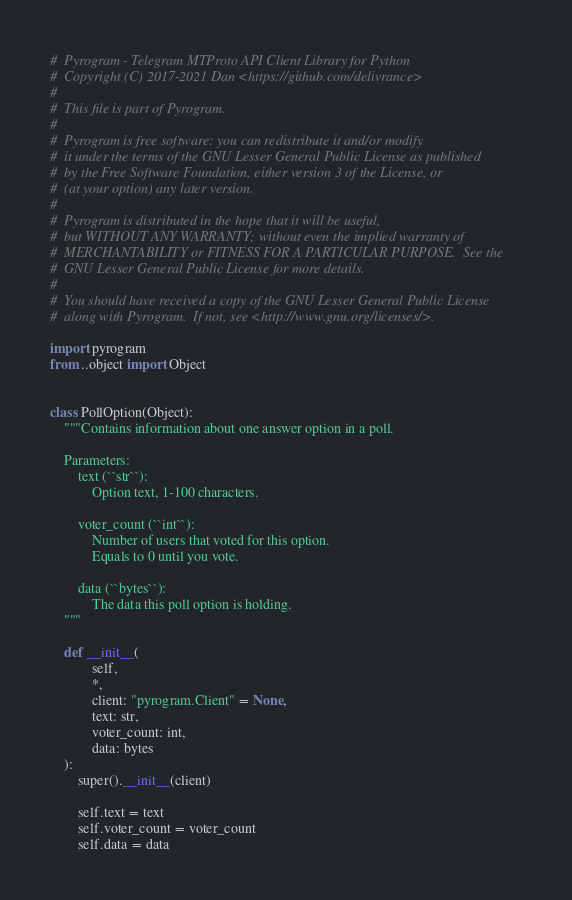<code> <loc_0><loc_0><loc_500><loc_500><_Python_>#  Pyrogram - Telegram MTProto API Client Library for Python
#  Copyright (C) 2017-2021 Dan <https://github.com/delivrance>
#
#  This file is part of Pyrogram.
#
#  Pyrogram is free software: you can redistribute it and/or modify
#  it under the terms of the GNU Lesser General Public License as published
#  by the Free Software Foundation, either version 3 of the License, or
#  (at your option) any later version.
#
#  Pyrogram is distributed in the hope that it will be useful,
#  but WITHOUT ANY WARRANTY; without even the implied warranty of
#  MERCHANTABILITY or FITNESS FOR A PARTICULAR PURPOSE.  See the
#  GNU Lesser General Public License for more details.
#
#  You should have received a copy of the GNU Lesser General Public License
#  along with Pyrogram.  If not, see <http://www.gnu.org/licenses/>.

import pyrogram
from ..object import Object


class PollOption(Object):
    """Contains information about one answer option in a poll.

    Parameters:
        text (``str``):
            Option text, 1-100 characters.

        voter_count (``int``):
            Number of users that voted for this option.
            Equals to 0 until you vote.

        data (``bytes``):
            The data this poll option is holding.
    """

    def __init__(
            self,
            *,
            client: "pyrogram.Client" = None,
            text: str,
            voter_count: int,
            data: bytes
    ):
        super().__init__(client)

        self.text = text
        self.voter_count = voter_count
        self.data = data
</code> 